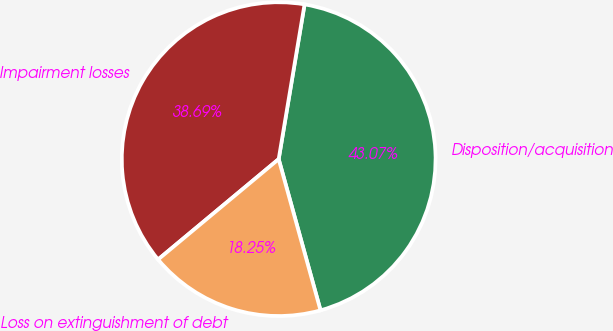Convert chart. <chart><loc_0><loc_0><loc_500><loc_500><pie_chart><fcel>Disposition/acquisition<fcel>Impairment losses<fcel>Loss on extinguishment of debt<nl><fcel>43.07%<fcel>38.69%<fcel>18.25%<nl></chart> 